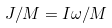<formula> <loc_0><loc_0><loc_500><loc_500>J / M = I \omega / M</formula> 